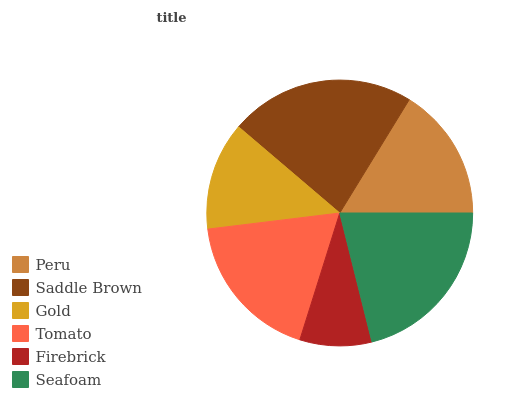Is Firebrick the minimum?
Answer yes or no. Yes. Is Saddle Brown the maximum?
Answer yes or no. Yes. Is Gold the minimum?
Answer yes or no. No. Is Gold the maximum?
Answer yes or no. No. Is Saddle Brown greater than Gold?
Answer yes or no. Yes. Is Gold less than Saddle Brown?
Answer yes or no. Yes. Is Gold greater than Saddle Brown?
Answer yes or no. No. Is Saddle Brown less than Gold?
Answer yes or no. No. Is Tomato the high median?
Answer yes or no. Yes. Is Peru the low median?
Answer yes or no. Yes. Is Peru the high median?
Answer yes or no. No. Is Tomato the low median?
Answer yes or no. No. 